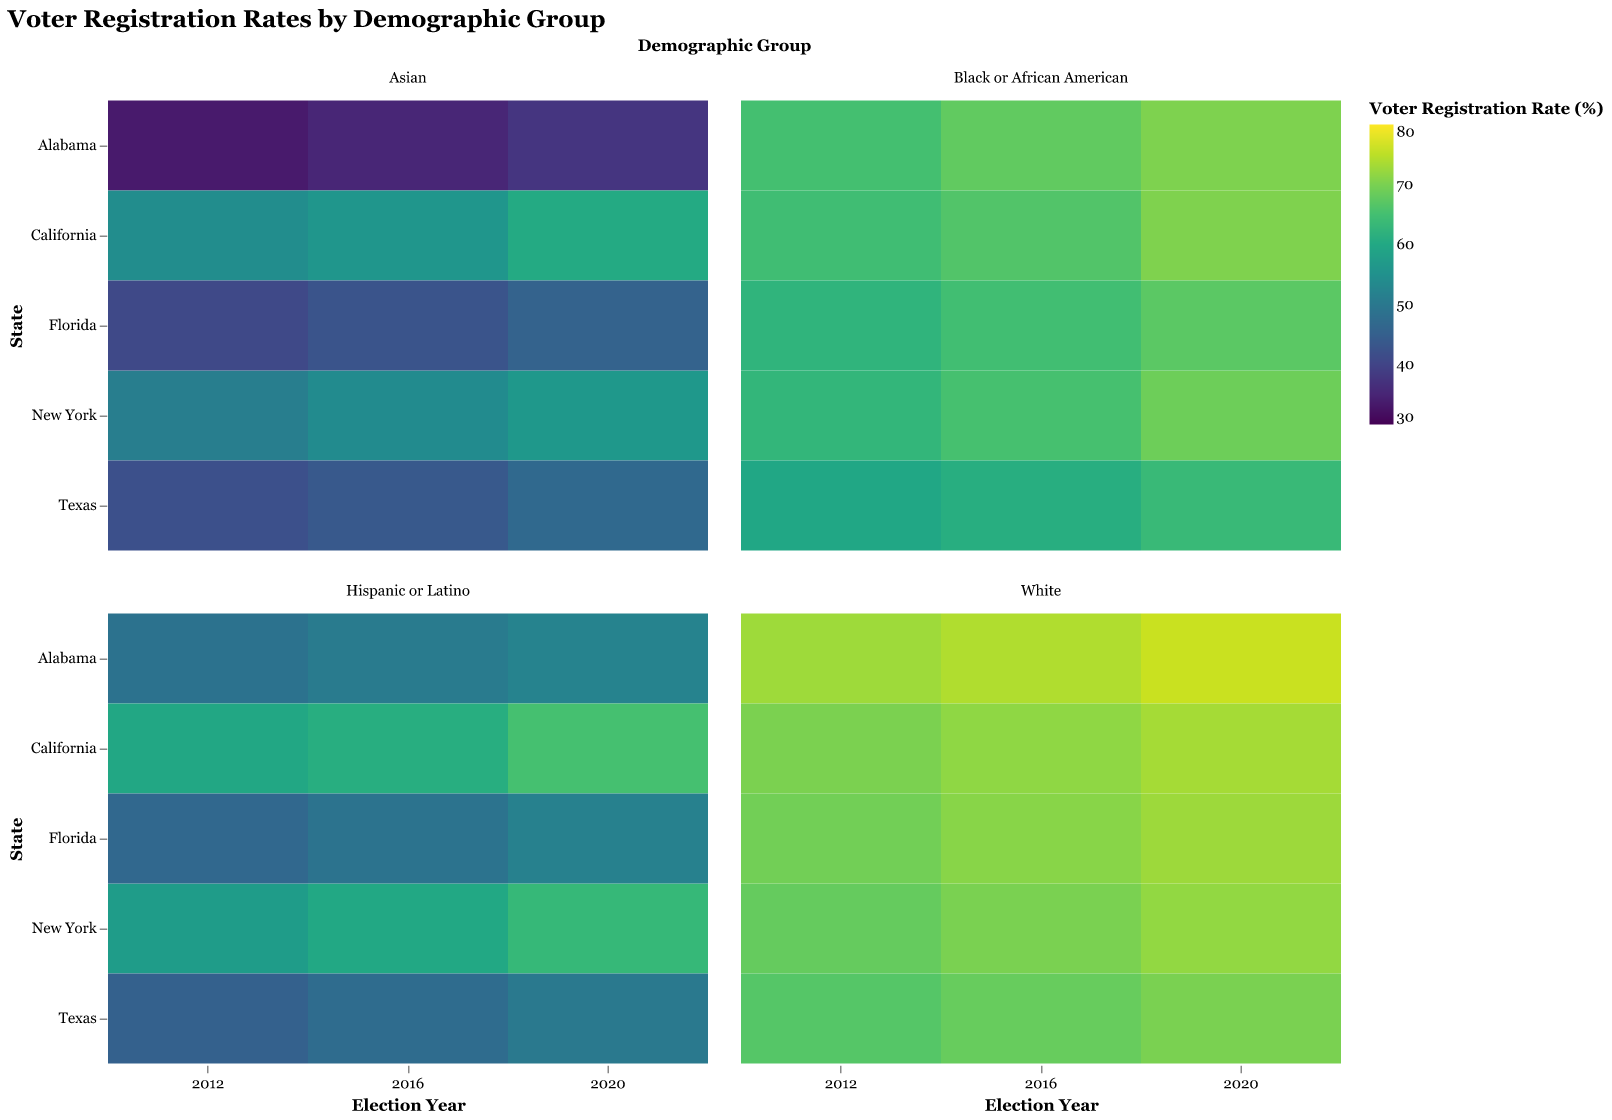What is the highest voter registration rate for "Black or African American" in 2020? To find this, look at the cells for "Black or African American" in the year 2020 across all states. The highest value can be found in the color intensity.
Answer: 70.4 Has voter registration for "Hispanic or Latino" in California increased or decreased from 2012 to 2020? Look at the "Hispanic or Latino" column for California in the years 2012 and 2020. Compare the values to see if it increased or decreased.
Answer: Increased Which state had the lowest voter registration rate for Asians in 2016? Look at the cells for "Asian" in 2016 and find the state with the lowest value by comparing the color intensity.
Answer: Alabama What is the average voter registration rate for "White" across all states in 2020? Find the "White" cells in 2020 for all states and calculate the average. Add all the values and divide by the number of states (5).
Answer: 72.78 In which state did "Black or African American" voter registration increase the most from 2012 to 2020? Look at the "Black or African American" cells from 2012 and 2020 across all states. Subtract the 2012 value from the 2020 value for each state and identify the state with the highest difference.
Answer: Florida How did voter registration for "Asians" in New York change from 2012 to 2020? Look at the "Asian" values for New York in 2012 and 2020. Compare the two values to see the change.
Answer: Increased Which demographic group showed the highest voter registration rate in any given state and year? Identify the highest single value across all demographic groups, states, and years by scanning for the darkest color intensity.
Answer: "White" in Alabama, 2020 Compare the voter registration rates for "Hispanic or Latino" in Texas and Florida in 2020. Which state had a higher rate? Look at the "Hispanic or Latino" cells for Texas and Florida in 2020. Compare the two values to see which is higher.
Answer: Florida What's the trend for voter registration rates for "Blacks or African Americans" in Alabama across the years shown? Look at the "Black or African American" values in Alabama for 2012, 2016, and 2020. Determine if the values are increasing, decreasing, or staying constant.
Answer: Increasing 